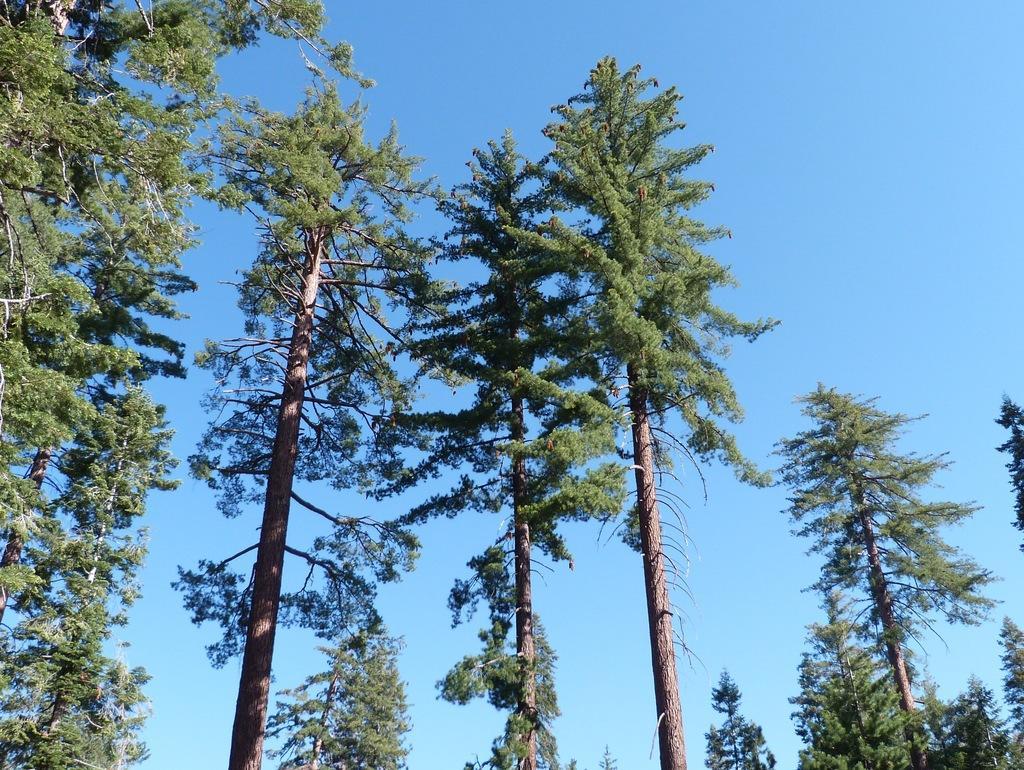Please provide a concise description of this image. In this image, we can see trees and in the background, there is sky. 